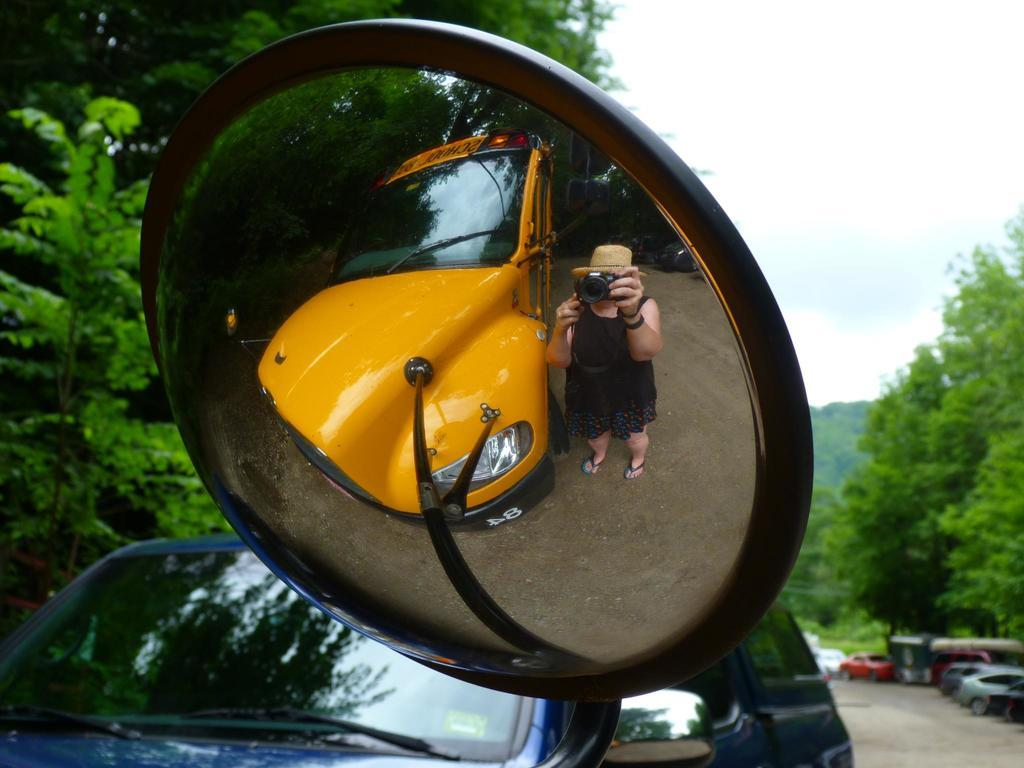What object in the image has a reflection? There is a mirror in the image that has a reflection. What can be seen in the mirror's reflection? The mirror's reflection shows a person holding a camera and a vehicle. What else is visible in the image besides the mirror? There are vehicles on the ground and trees in the image. What can be seen in the background of the image? The sky is visible in the background of the image. What type of brick is being used to build the monkey's vacation home in the image? There is no brick, monkey, or vacation home present in the image. 